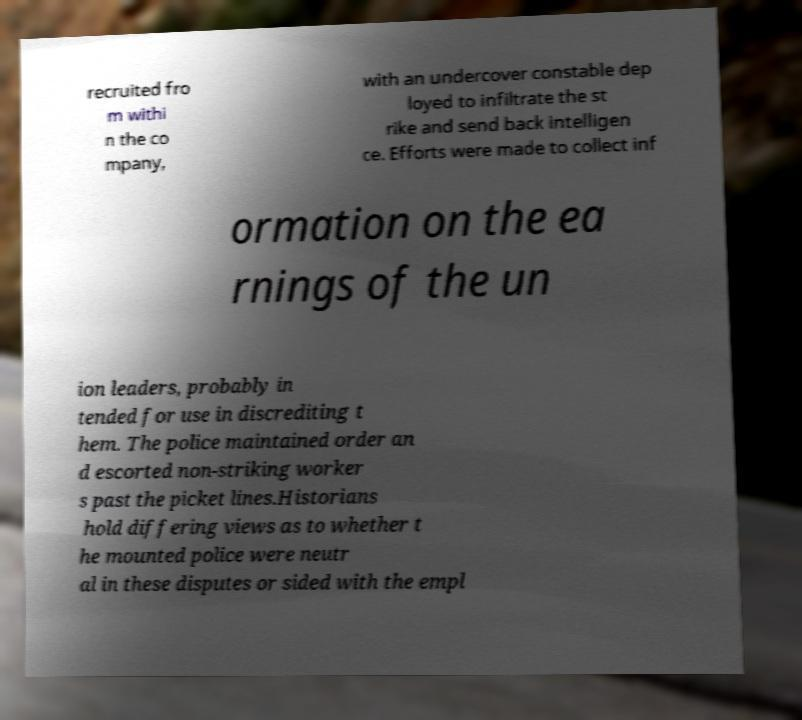Could you extract and type out the text from this image? recruited fro m withi n the co mpany, with an undercover constable dep loyed to infiltrate the st rike and send back intelligen ce. Efforts were made to collect inf ormation on the ea rnings of the un ion leaders, probably in tended for use in discrediting t hem. The police maintained order an d escorted non-striking worker s past the picket lines.Historians hold differing views as to whether t he mounted police were neutr al in these disputes or sided with the empl 